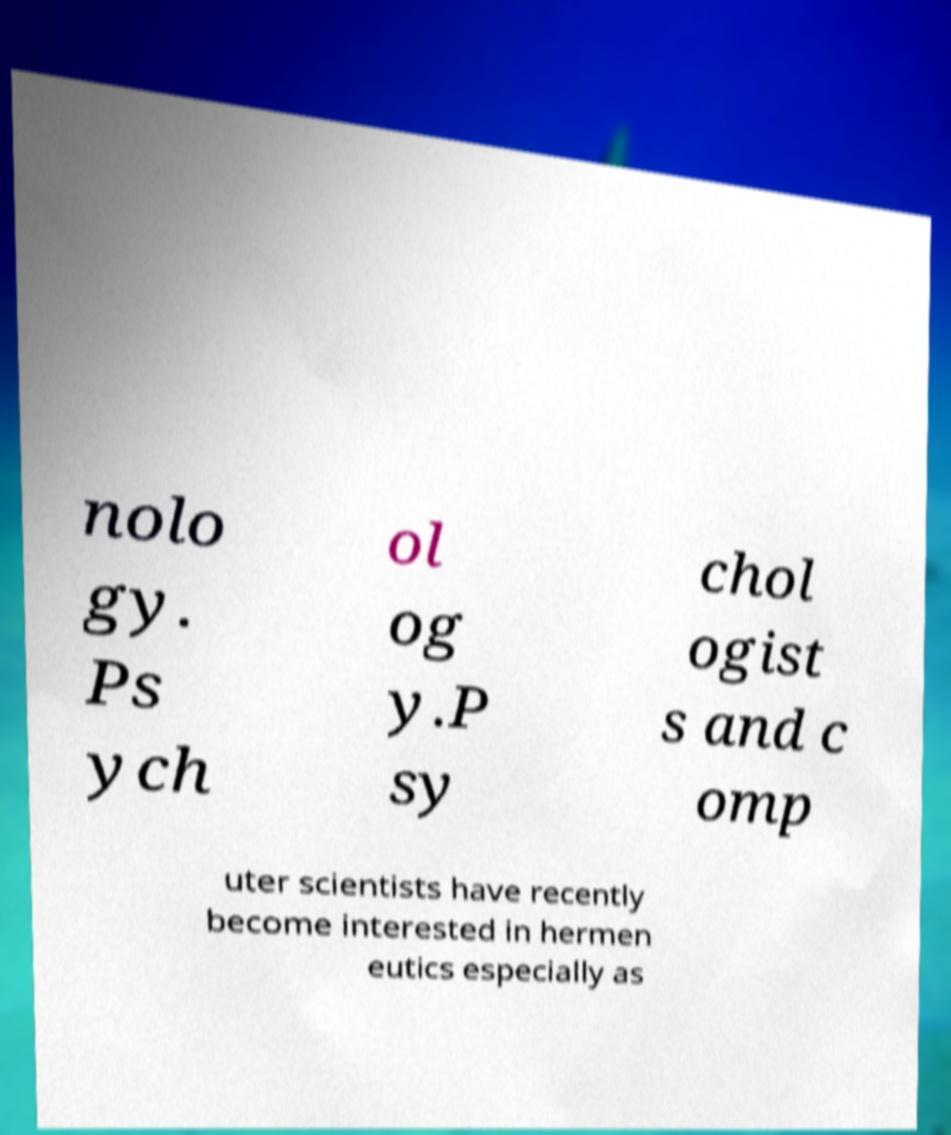I need the written content from this picture converted into text. Can you do that? nolo gy. Ps ych ol og y.P sy chol ogist s and c omp uter scientists have recently become interested in hermen eutics especially as 